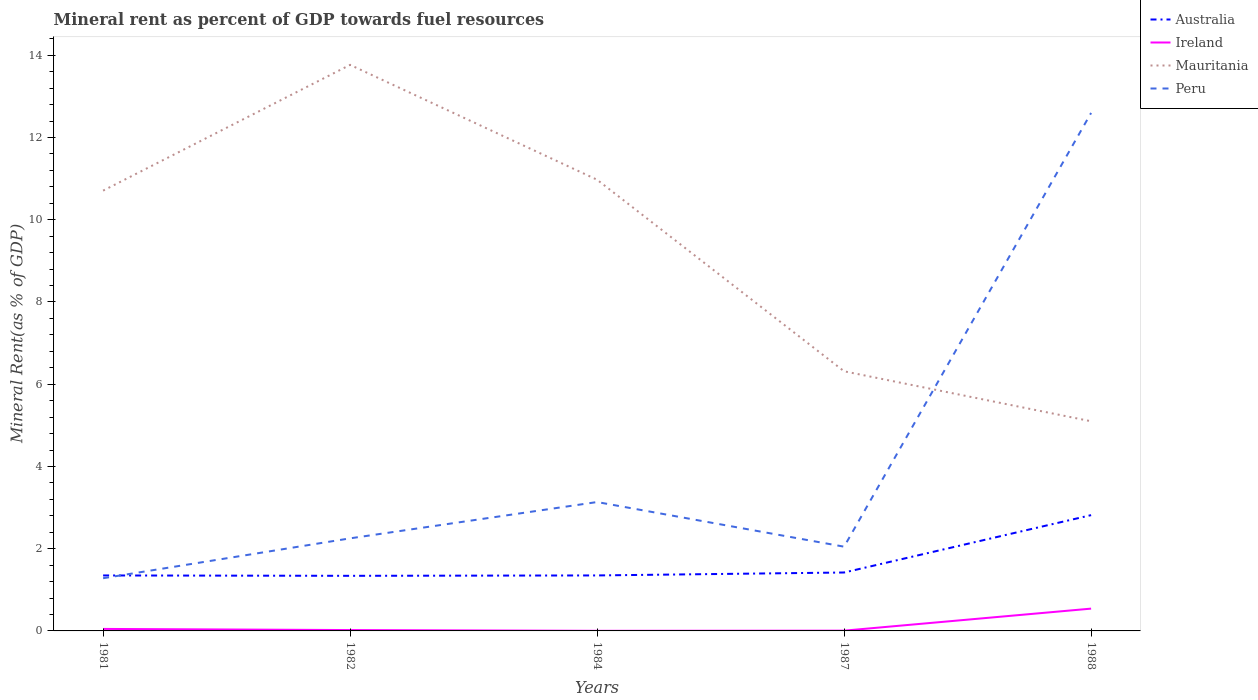Across all years, what is the maximum mineral rent in Mauritania?
Your answer should be very brief. 5.1. In which year was the mineral rent in Australia maximum?
Provide a short and direct response. 1982. What is the total mineral rent in Australia in the graph?
Provide a short and direct response. -0.08. What is the difference between the highest and the second highest mineral rent in Mauritania?
Make the answer very short. 8.67. How many lines are there?
Offer a very short reply. 4. How many years are there in the graph?
Your response must be concise. 5. What is the difference between two consecutive major ticks on the Y-axis?
Keep it short and to the point. 2. How many legend labels are there?
Give a very brief answer. 4. What is the title of the graph?
Offer a very short reply. Mineral rent as percent of GDP towards fuel resources. Does "Syrian Arab Republic" appear as one of the legend labels in the graph?
Ensure brevity in your answer.  No. What is the label or title of the Y-axis?
Provide a short and direct response. Mineral Rent(as % of GDP). What is the Mineral Rent(as % of GDP) in Australia in 1981?
Offer a very short reply. 1.35. What is the Mineral Rent(as % of GDP) in Ireland in 1981?
Provide a succinct answer. 0.05. What is the Mineral Rent(as % of GDP) of Mauritania in 1981?
Your answer should be very brief. 10.71. What is the Mineral Rent(as % of GDP) of Peru in 1981?
Offer a very short reply. 1.28. What is the Mineral Rent(as % of GDP) of Australia in 1982?
Make the answer very short. 1.34. What is the Mineral Rent(as % of GDP) of Ireland in 1982?
Offer a terse response. 0.02. What is the Mineral Rent(as % of GDP) in Mauritania in 1982?
Make the answer very short. 13.77. What is the Mineral Rent(as % of GDP) in Peru in 1982?
Provide a short and direct response. 2.25. What is the Mineral Rent(as % of GDP) of Australia in 1984?
Your response must be concise. 1.35. What is the Mineral Rent(as % of GDP) in Ireland in 1984?
Make the answer very short. 0. What is the Mineral Rent(as % of GDP) in Mauritania in 1984?
Your response must be concise. 10.97. What is the Mineral Rent(as % of GDP) in Peru in 1984?
Give a very brief answer. 3.13. What is the Mineral Rent(as % of GDP) in Australia in 1987?
Ensure brevity in your answer.  1.42. What is the Mineral Rent(as % of GDP) of Ireland in 1987?
Provide a succinct answer. 0.01. What is the Mineral Rent(as % of GDP) in Mauritania in 1987?
Give a very brief answer. 6.31. What is the Mineral Rent(as % of GDP) of Peru in 1987?
Make the answer very short. 2.05. What is the Mineral Rent(as % of GDP) of Australia in 1988?
Offer a very short reply. 2.82. What is the Mineral Rent(as % of GDP) of Ireland in 1988?
Your response must be concise. 0.54. What is the Mineral Rent(as % of GDP) in Mauritania in 1988?
Provide a short and direct response. 5.1. What is the Mineral Rent(as % of GDP) of Peru in 1988?
Ensure brevity in your answer.  12.6. Across all years, what is the maximum Mineral Rent(as % of GDP) of Australia?
Ensure brevity in your answer.  2.82. Across all years, what is the maximum Mineral Rent(as % of GDP) of Ireland?
Your response must be concise. 0.54. Across all years, what is the maximum Mineral Rent(as % of GDP) of Mauritania?
Keep it short and to the point. 13.77. Across all years, what is the maximum Mineral Rent(as % of GDP) in Peru?
Keep it short and to the point. 12.6. Across all years, what is the minimum Mineral Rent(as % of GDP) of Australia?
Your answer should be very brief. 1.34. Across all years, what is the minimum Mineral Rent(as % of GDP) in Ireland?
Keep it short and to the point. 0. Across all years, what is the minimum Mineral Rent(as % of GDP) of Mauritania?
Keep it short and to the point. 5.1. Across all years, what is the minimum Mineral Rent(as % of GDP) of Peru?
Provide a succinct answer. 1.28. What is the total Mineral Rent(as % of GDP) in Australia in the graph?
Give a very brief answer. 8.28. What is the total Mineral Rent(as % of GDP) in Ireland in the graph?
Offer a very short reply. 0.62. What is the total Mineral Rent(as % of GDP) in Mauritania in the graph?
Your answer should be compact. 46.86. What is the total Mineral Rent(as % of GDP) in Peru in the graph?
Offer a very short reply. 21.31. What is the difference between the Mineral Rent(as % of GDP) in Australia in 1981 and that in 1982?
Your response must be concise. 0.01. What is the difference between the Mineral Rent(as % of GDP) of Ireland in 1981 and that in 1982?
Offer a very short reply. 0.03. What is the difference between the Mineral Rent(as % of GDP) of Mauritania in 1981 and that in 1982?
Offer a very short reply. -3.06. What is the difference between the Mineral Rent(as % of GDP) in Peru in 1981 and that in 1982?
Provide a short and direct response. -0.97. What is the difference between the Mineral Rent(as % of GDP) of Australia in 1981 and that in 1984?
Your response must be concise. -0. What is the difference between the Mineral Rent(as % of GDP) of Ireland in 1981 and that in 1984?
Give a very brief answer. 0.05. What is the difference between the Mineral Rent(as % of GDP) of Mauritania in 1981 and that in 1984?
Make the answer very short. -0.27. What is the difference between the Mineral Rent(as % of GDP) of Peru in 1981 and that in 1984?
Provide a succinct answer. -1.85. What is the difference between the Mineral Rent(as % of GDP) of Australia in 1981 and that in 1987?
Provide a succinct answer. -0.07. What is the difference between the Mineral Rent(as % of GDP) in Ireland in 1981 and that in 1987?
Give a very brief answer. 0.04. What is the difference between the Mineral Rent(as % of GDP) in Mauritania in 1981 and that in 1987?
Your answer should be compact. 4.39. What is the difference between the Mineral Rent(as % of GDP) of Peru in 1981 and that in 1987?
Offer a terse response. -0.77. What is the difference between the Mineral Rent(as % of GDP) in Australia in 1981 and that in 1988?
Offer a terse response. -1.47. What is the difference between the Mineral Rent(as % of GDP) of Ireland in 1981 and that in 1988?
Your response must be concise. -0.49. What is the difference between the Mineral Rent(as % of GDP) in Mauritania in 1981 and that in 1988?
Offer a terse response. 5.61. What is the difference between the Mineral Rent(as % of GDP) in Peru in 1981 and that in 1988?
Offer a terse response. -11.32. What is the difference between the Mineral Rent(as % of GDP) in Australia in 1982 and that in 1984?
Keep it short and to the point. -0.01. What is the difference between the Mineral Rent(as % of GDP) of Ireland in 1982 and that in 1984?
Give a very brief answer. 0.02. What is the difference between the Mineral Rent(as % of GDP) of Mauritania in 1982 and that in 1984?
Provide a succinct answer. 2.79. What is the difference between the Mineral Rent(as % of GDP) of Peru in 1982 and that in 1984?
Your answer should be very brief. -0.88. What is the difference between the Mineral Rent(as % of GDP) in Australia in 1982 and that in 1987?
Your answer should be very brief. -0.08. What is the difference between the Mineral Rent(as % of GDP) in Ireland in 1982 and that in 1987?
Give a very brief answer. 0.01. What is the difference between the Mineral Rent(as % of GDP) in Mauritania in 1982 and that in 1987?
Your answer should be compact. 7.45. What is the difference between the Mineral Rent(as % of GDP) of Peru in 1982 and that in 1987?
Your answer should be compact. 0.2. What is the difference between the Mineral Rent(as % of GDP) of Australia in 1982 and that in 1988?
Give a very brief answer. -1.48. What is the difference between the Mineral Rent(as % of GDP) in Ireland in 1982 and that in 1988?
Your answer should be very brief. -0.52. What is the difference between the Mineral Rent(as % of GDP) in Mauritania in 1982 and that in 1988?
Your answer should be compact. 8.67. What is the difference between the Mineral Rent(as % of GDP) of Peru in 1982 and that in 1988?
Your answer should be very brief. -10.35. What is the difference between the Mineral Rent(as % of GDP) of Australia in 1984 and that in 1987?
Your answer should be compact. -0.07. What is the difference between the Mineral Rent(as % of GDP) in Ireland in 1984 and that in 1987?
Offer a terse response. -0. What is the difference between the Mineral Rent(as % of GDP) in Mauritania in 1984 and that in 1987?
Make the answer very short. 4.66. What is the difference between the Mineral Rent(as % of GDP) in Peru in 1984 and that in 1987?
Give a very brief answer. 1.09. What is the difference between the Mineral Rent(as % of GDP) in Australia in 1984 and that in 1988?
Keep it short and to the point. -1.47. What is the difference between the Mineral Rent(as % of GDP) in Ireland in 1984 and that in 1988?
Your answer should be very brief. -0.54. What is the difference between the Mineral Rent(as % of GDP) of Mauritania in 1984 and that in 1988?
Provide a short and direct response. 5.87. What is the difference between the Mineral Rent(as % of GDP) of Peru in 1984 and that in 1988?
Your answer should be compact. -9.46. What is the difference between the Mineral Rent(as % of GDP) in Australia in 1987 and that in 1988?
Your response must be concise. -1.4. What is the difference between the Mineral Rent(as % of GDP) in Ireland in 1987 and that in 1988?
Keep it short and to the point. -0.54. What is the difference between the Mineral Rent(as % of GDP) of Mauritania in 1987 and that in 1988?
Keep it short and to the point. 1.22. What is the difference between the Mineral Rent(as % of GDP) of Peru in 1987 and that in 1988?
Your answer should be very brief. -10.55. What is the difference between the Mineral Rent(as % of GDP) in Australia in 1981 and the Mineral Rent(as % of GDP) in Ireland in 1982?
Make the answer very short. 1.33. What is the difference between the Mineral Rent(as % of GDP) of Australia in 1981 and the Mineral Rent(as % of GDP) of Mauritania in 1982?
Provide a succinct answer. -12.42. What is the difference between the Mineral Rent(as % of GDP) in Australia in 1981 and the Mineral Rent(as % of GDP) in Peru in 1982?
Provide a short and direct response. -0.9. What is the difference between the Mineral Rent(as % of GDP) of Ireland in 1981 and the Mineral Rent(as % of GDP) of Mauritania in 1982?
Provide a succinct answer. -13.72. What is the difference between the Mineral Rent(as % of GDP) of Ireland in 1981 and the Mineral Rent(as % of GDP) of Peru in 1982?
Keep it short and to the point. -2.2. What is the difference between the Mineral Rent(as % of GDP) of Mauritania in 1981 and the Mineral Rent(as % of GDP) of Peru in 1982?
Provide a succinct answer. 8.46. What is the difference between the Mineral Rent(as % of GDP) of Australia in 1981 and the Mineral Rent(as % of GDP) of Ireland in 1984?
Your answer should be compact. 1.35. What is the difference between the Mineral Rent(as % of GDP) in Australia in 1981 and the Mineral Rent(as % of GDP) in Mauritania in 1984?
Your answer should be very brief. -9.62. What is the difference between the Mineral Rent(as % of GDP) in Australia in 1981 and the Mineral Rent(as % of GDP) in Peru in 1984?
Provide a short and direct response. -1.79. What is the difference between the Mineral Rent(as % of GDP) of Ireland in 1981 and the Mineral Rent(as % of GDP) of Mauritania in 1984?
Your response must be concise. -10.92. What is the difference between the Mineral Rent(as % of GDP) of Ireland in 1981 and the Mineral Rent(as % of GDP) of Peru in 1984?
Give a very brief answer. -3.09. What is the difference between the Mineral Rent(as % of GDP) of Mauritania in 1981 and the Mineral Rent(as % of GDP) of Peru in 1984?
Offer a terse response. 7.57. What is the difference between the Mineral Rent(as % of GDP) of Australia in 1981 and the Mineral Rent(as % of GDP) of Ireland in 1987?
Make the answer very short. 1.34. What is the difference between the Mineral Rent(as % of GDP) of Australia in 1981 and the Mineral Rent(as % of GDP) of Mauritania in 1987?
Keep it short and to the point. -4.97. What is the difference between the Mineral Rent(as % of GDP) in Australia in 1981 and the Mineral Rent(as % of GDP) in Peru in 1987?
Keep it short and to the point. -0.7. What is the difference between the Mineral Rent(as % of GDP) of Ireland in 1981 and the Mineral Rent(as % of GDP) of Mauritania in 1987?
Give a very brief answer. -6.27. What is the difference between the Mineral Rent(as % of GDP) in Ireland in 1981 and the Mineral Rent(as % of GDP) in Peru in 1987?
Provide a short and direct response. -2. What is the difference between the Mineral Rent(as % of GDP) of Mauritania in 1981 and the Mineral Rent(as % of GDP) of Peru in 1987?
Offer a very short reply. 8.66. What is the difference between the Mineral Rent(as % of GDP) in Australia in 1981 and the Mineral Rent(as % of GDP) in Ireland in 1988?
Your response must be concise. 0.81. What is the difference between the Mineral Rent(as % of GDP) of Australia in 1981 and the Mineral Rent(as % of GDP) of Mauritania in 1988?
Provide a short and direct response. -3.75. What is the difference between the Mineral Rent(as % of GDP) in Australia in 1981 and the Mineral Rent(as % of GDP) in Peru in 1988?
Make the answer very short. -11.25. What is the difference between the Mineral Rent(as % of GDP) in Ireland in 1981 and the Mineral Rent(as % of GDP) in Mauritania in 1988?
Provide a succinct answer. -5.05. What is the difference between the Mineral Rent(as % of GDP) of Ireland in 1981 and the Mineral Rent(as % of GDP) of Peru in 1988?
Offer a very short reply. -12.55. What is the difference between the Mineral Rent(as % of GDP) of Mauritania in 1981 and the Mineral Rent(as % of GDP) of Peru in 1988?
Keep it short and to the point. -1.89. What is the difference between the Mineral Rent(as % of GDP) in Australia in 1982 and the Mineral Rent(as % of GDP) in Ireland in 1984?
Make the answer very short. 1.34. What is the difference between the Mineral Rent(as % of GDP) of Australia in 1982 and the Mineral Rent(as % of GDP) of Mauritania in 1984?
Your response must be concise. -9.63. What is the difference between the Mineral Rent(as % of GDP) in Australia in 1982 and the Mineral Rent(as % of GDP) in Peru in 1984?
Your answer should be very brief. -1.79. What is the difference between the Mineral Rent(as % of GDP) of Ireland in 1982 and the Mineral Rent(as % of GDP) of Mauritania in 1984?
Ensure brevity in your answer.  -10.95. What is the difference between the Mineral Rent(as % of GDP) in Ireland in 1982 and the Mineral Rent(as % of GDP) in Peru in 1984?
Make the answer very short. -3.11. What is the difference between the Mineral Rent(as % of GDP) in Mauritania in 1982 and the Mineral Rent(as % of GDP) in Peru in 1984?
Your answer should be compact. 10.63. What is the difference between the Mineral Rent(as % of GDP) in Australia in 1982 and the Mineral Rent(as % of GDP) in Ireland in 1987?
Offer a terse response. 1.33. What is the difference between the Mineral Rent(as % of GDP) of Australia in 1982 and the Mineral Rent(as % of GDP) of Mauritania in 1987?
Offer a very short reply. -4.97. What is the difference between the Mineral Rent(as % of GDP) of Australia in 1982 and the Mineral Rent(as % of GDP) of Peru in 1987?
Give a very brief answer. -0.71. What is the difference between the Mineral Rent(as % of GDP) in Ireland in 1982 and the Mineral Rent(as % of GDP) in Mauritania in 1987?
Offer a terse response. -6.29. What is the difference between the Mineral Rent(as % of GDP) in Ireland in 1982 and the Mineral Rent(as % of GDP) in Peru in 1987?
Offer a terse response. -2.03. What is the difference between the Mineral Rent(as % of GDP) of Mauritania in 1982 and the Mineral Rent(as % of GDP) of Peru in 1987?
Your response must be concise. 11.72. What is the difference between the Mineral Rent(as % of GDP) of Australia in 1982 and the Mineral Rent(as % of GDP) of Ireland in 1988?
Your answer should be very brief. 0.8. What is the difference between the Mineral Rent(as % of GDP) in Australia in 1982 and the Mineral Rent(as % of GDP) in Mauritania in 1988?
Provide a succinct answer. -3.76. What is the difference between the Mineral Rent(as % of GDP) of Australia in 1982 and the Mineral Rent(as % of GDP) of Peru in 1988?
Give a very brief answer. -11.26. What is the difference between the Mineral Rent(as % of GDP) in Ireland in 1982 and the Mineral Rent(as % of GDP) in Mauritania in 1988?
Ensure brevity in your answer.  -5.08. What is the difference between the Mineral Rent(as % of GDP) of Ireland in 1982 and the Mineral Rent(as % of GDP) of Peru in 1988?
Make the answer very short. -12.58. What is the difference between the Mineral Rent(as % of GDP) in Mauritania in 1982 and the Mineral Rent(as % of GDP) in Peru in 1988?
Offer a terse response. 1.17. What is the difference between the Mineral Rent(as % of GDP) in Australia in 1984 and the Mineral Rent(as % of GDP) in Ireland in 1987?
Your answer should be very brief. 1.34. What is the difference between the Mineral Rent(as % of GDP) of Australia in 1984 and the Mineral Rent(as % of GDP) of Mauritania in 1987?
Provide a succinct answer. -4.96. What is the difference between the Mineral Rent(as % of GDP) in Australia in 1984 and the Mineral Rent(as % of GDP) in Peru in 1987?
Provide a short and direct response. -0.7. What is the difference between the Mineral Rent(as % of GDP) in Ireland in 1984 and the Mineral Rent(as % of GDP) in Mauritania in 1987?
Give a very brief answer. -6.31. What is the difference between the Mineral Rent(as % of GDP) of Ireland in 1984 and the Mineral Rent(as % of GDP) of Peru in 1987?
Your response must be concise. -2.05. What is the difference between the Mineral Rent(as % of GDP) of Mauritania in 1984 and the Mineral Rent(as % of GDP) of Peru in 1987?
Make the answer very short. 8.92. What is the difference between the Mineral Rent(as % of GDP) of Australia in 1984 and the Mineral Rent(as % of GDP) of Ireland in 1988?
Your answer should be compact. 0.81. What is the difference between the Mineral Rent(as % of GDP) of Australia in 1984 and the Mineral Rent(as % of GDP) of Mauritania in 1988?
Your response must be concise. -3.75. What is the difference between the Mineral Rent(as % of GDP) in Australia in 1984 and the Mineral Rent(as % of GDP) in Peru in 1988?
Your response must be concise. -11.25. What is the difference between the Mineral Rent(as % of GDP) of Ireland in 1984 and the Mineral Rent(as % of GDP) of Mauritania in 1988?
Provide a succinct answer. -5.1. What is the difference between the Mineral Rent(as % of GDP) in Ireland in 1984 and the Mineral Rent(as % of GDP) in Peru in 1988?
Your response must be concise. -12.6. What is the difference between the Mineral Rent(as % of GDP) of Mauritania in 1984 and the Mineral Rent(as % of GDP) of Peru in 1988?
Provide a short and direct response. -1.62. What is the difference between the Mineral Rent(as % of GDP) in Australia in 1987 and the Mineral Rent(as % of GDP) in Ireland in 1988?
Your answer should be compact. 0.88. What is the difference between the Mineral Rent(as % of GDP) in Australia in 1987 and the Mineral Rent(as % of GDP) in Mauritania in 1988?
Your answer should be very brief. -3.68. What is the difference between the Mineral Rent(as % of GDP) in Australia in 1987 and the Mineral Rent(as % of GDP) in Peru in 1988?
Offer a terse response. -11.18. What is the difference between the Mineral Rent(as % of GDP) in Ireland in 1987 and the Mineral Rent(as % of GDP) in Mauritania in 1988?
Offer a very short reply. -5.09. What is the difference between the Mineral Rent(as % of GDP) of Ireland in 1987 and the Mineral Rent(as % of GDP) of Peru in 1988?
Ensure brevity in your answer.  -12.59. What is the difference between the Mineral Rent(as % of GDP) of Mauritania in 1987 and the Mineral Rent(as % of GDP) of Peru in 1988?
Your answer should be very brief. -6.28. What is the average Mineral Rent(as % of GDP) of Australia per year?
Offer a very short reply. 1.66. What is the average Mineral Rent(as % of GDP) of Ireland per year?
Offer a very short reply. 0.12. What is the average Mineral Rent(as % of GDP) in Mauritania per year?
Offer a very short reply. 9.37. What is the average Mineral Rent(as % of GDP) of Peru per year?
Your answer should be compact. 4.26. In the year 1981, what is the difference between the Mineral Rent(as % of GDP) of Australia and Mineral Rent(as % of GDP) of Ireland?
Your response must be concise. 1.3. In the year 1981, what is the difference between the Mineral Rent(as % of GDP) in Australia and Mineral Rent(as % of GDP) in Mauritania?
Offer a very short reply. -9.36. In the year 1981, what is the difference between the Mineral Rent(as % of GDP) in Australia and Mineral Rent(as % of GDP) in Peru?
Provide a succinct answer. 0.07. In the year 1981, what is the difference between the Mineral Rent(as % of GDP) of Ireland and Mineral Rent(as % of GDP) of Mauritania?
Give a very brief answer. -10.66. In the year 1981, what is the difference between the Mineral Rent(as % of GDP) in Ireland and Mineral Rent(as % of GDP) in Peru?
Provide a succinct answer. -1.23. In the year 1981, what is the difference between the Mineral Rent(as % of GDP) of Mauritania and Mineral Rent(as % of GDP) of Peru?
Offer a terse response. 9.43. In the year 1982, what is the difference between the Mineral Rent(as % of GDP) of Australia and Mineral Rent(as % of GDP) of Ireland?
Your answer should be compact. 1.32. In the year 1982, what is the difference between the Mineral Rent(as % of GDP) in Australia and Mineral Rent(as % of GDP) in Mauritania?
Your response must be concise. -12.43. In the year 1982, what is the difference between the Mineral Rent(as % of GDP) of Australia and Mineral Rent(as % of GDP) of Peru?
Provide a short and direct response. -0.91. In the year 1982, what is the difference between the Mineral Rent(as % of GDP) in Ireland and Mineral Rent(as % of GDP) in Mauritania?
Give a very brief answer. -13.75. In the year 1982, what is the difference between the Mineral Rent(as % of GDP) of Ireland and Mineral Rent(as % of GDP) of Peru?
Ensure brevity in your answer.  -2.23. In the year 1982, what is the difference between the Mineral Rent(as % of GDP) in Mauritania and Mineral Rent(as % of GDP) in Peru?
Your answer should be compact. 11.52. In the year 1984, what is the difference between the Mineral Rent(as % of GDP) in Australia and Mineral Rent(as % of GDP) in Ireland?
Your response must be concise. 1.35. In the year 1984, what is the difference between the Mineral Rent(as % of GDP) in Australia and Mineral Rent(as % of GDP) in Mauritania?
Offer a very short reply. -9.62. In the year 1984, what is the difference between the Mineral Rent(as % of GDP) of Australia and Mineral Rent(as % of GDP) of Peru?
Ensure brevity in your answer.  -1.78. In the year 1984, what is the difference between the Mineral Rent(as % of GDP) of Ireland and Mineral Rent(as % of GDP) of Mauritania?
Provide a short and direct response. -10.97. In the year 1984, what is the difference between the Mineral Rent(as % of GDP) of Ireland and Mineral Rent(as % of GDP) of Peru?
Your answer should be very brief. -3.13. In the year 1984, what is the difference between the Mineral Rent(as % of GDP) in Mauritania and Mineral Rent(as % of GDP) in Peru?
Give a very brief answer. 7.84. In the year 1987, what is the difference between the Mineral Rent(as % of GDP) of Australia and Mineral Rent(as % of GDP) of Ireland?
Your response must be concise. 1.41. In the year 1987, what is the difference between the Mineral Rent(as % of GDP) in Australia and Mineral Rent(as % of GDP) in Mauritania?
Offer a terse response. -4.89. In the year 1987, what is the difference between the Mineral Rent(as % of GDP) of Australia and Mineral Rent(as % of GDP) of Peru?
Make the answer very short. -0.63. In the year 1987, what is the difference between the Mineral Rent(as % of GDP) of Ireland and Mineral Rent(as % of GDP) of Mauritania?
Offer a very short reply. -6.31. In the year 1987, what is the difference between the Mineral Rent(as % of GDP) in Ireland and Mineral Rent(as % of GDP) in Peru?
Provide a succinct answer. -2.04. In the year 1987, what is the difference between the Mineral Rent(as % of GDP) in Mauritania and Mineral Rent(as % of GDP) in Peru?
Provide a short and direct response. 4.27. In the year 1988, what is the difference between the Mineral Rent(as % of GDP) of Australia and Mineral Rent(as % of GDP) of Ireland?
Ensure brevity in your answer.  2.27. In the year 1988, what is the difference between the Mineral Rent(as % of GDP) of Australia and Mineral Rent(as % of GDP) of Mauritania?
Provide a succinct answer. -2.28. In the year 1988, what is the difference between the Mineral Rent(as % of GDP) in Australia and Mineral Rent(as % of GDP) in Peru?
Your answer should be very brief. -9.78. In the year 1988, what is the difference between the Mineral Rent(as % of GDP) of Ireland and Mineral Rent(as % of GDP) of Mauritania?
Provide a short and direct response. -4.56. In the year 1988, what is the difference between the Mineral Rent(as % of GDP) in Ireland and Mineral Rent(as % of GDP) in Peru?
Provide a short and direct response. -12.06. In the year 1988, what is the difference between the Mineral Rent(as % of GDP) in Mauritania and Mineral Rent(as % of GDP) in Peru?
Make the answer very short. -7.5. What is the ratio of the Mineral Rent(as % of GDP) in Australia in 1981 to that in 1982?
Give a very brief answer. 1.01. What is the ratio of the Mineral Rent(as % of GDP) of Ireland in 1981 to that in 1982?
Your answer should be compact. 2.33. What is the ratio of the Mineral Rent(as % of GDP) in Peru in 1981 to that in 1982?
Offer a terse response. 0.57. What is the ratio of the Mineral Rent(as % of GDP) in Ireland in 1981 to that in 1984?
Your response must be concise. 17.88. What is the ratio of the Mineral Rent(as % of GDP) of Mauritania in 1981 to that in 1984?
Your answer should be very brief. 0.98. What is the ratio of the Mineral Rent(as % of GDP) of Peru in 1981 to that in 1984?
Provide a short and direct response. 0.41. What is the ratio of the Mineral Rent(as % of GDP) of Australia in 1981 to that in 1987?
Offer a terse response. 0.95. What is the ratio of the Mineral Rent(as % of GDP) of Ireland in 1981 to that in 1987?
Offer a terse response. 7.66. What is the ratio of the Mineral Rent(as % of GDP) of Mauritania in 1981 to that in 1987?
Make the answer very short. 1.7. What is the ratio of the Mineral Rent(as % of GDP) in Peru in 1981 to that in 1987?
Provide a short and direct response. 0.63. What is the ratio of the Mineral Rent(as % of GDP) in Australia in 1981 to that in 1988?
Provide a succinct answer. 0.48. What is the ratio of the Mineral Rent(as % of GDP) in Ireland in 1981 to that in 1988?
Offer a very short reply. 0.09. What is the ratio of the Mineral Rent(as % of GDP) in Mauritania in 1981 to that in 1988?
Offer a terse response. 2.1. What is the ratio of the Mineral Rent(as % of GDP) in Peru in 1981 to that in 1988?
Your answer should be compact. 0.1. What is the ratio of the Mineral Rent(as % of GDP) in Ireland in 1982 to that in 1984?
Your answer should be very brief. 7.68. What is the ratio of the Mineral Rent(as % of GDP) of Mauritania in 1982 to that in 1984?
Your answer should be very brief. 1.25. What is the ratio of the Mineral Rent(as % of GDP) in Peru in 1982 to that in 1984?
Your answer should be compact. 0.72. What is the ratio of the Mineral Rent(as % of GDP) in Australia in 1982 to that in 1987?
Provide a short and direct response. 0.94. What is the ratio of the Mineral Rent(as % of GDP) of Ireland in 1982 to that in 1987?
Provide a short and direct response. 3.29. What is the ratio of the Mineral Rent(as % of GDP) in Mauritania in 1982 to that in 1987?
Your response must be concise. 2.18. What is the ratio of the Mineral Rent(as % of GDP) of Peru in 1982 to that in 1987?
Your answer should be compact. 1.1. What is the ratio of the Mineral Rent(as % of GDP) of Australia in 1982 to that in 1988?
Provide a succinct answer. 0.48. What is the ratio of the Mineral Rent(as % of GDP) in Ireland in 1982 to that in 1988?
Make the answer very short. 0.04. What is the ratio of the Mineral Rent(as % of GDP) in Mauritania in 1982 to that in 1988?
Your answer should be very brief. 2.7. What is the ratio of the Mineral Rent(as % of GDP) of Peru in 1982 to that in 1988?
Give a very brief answer. 0.18. What is the ratio of the Mineral Rent(as % of GDP) in Australia in 1984 to that in 1987?
Offer a very short reply. 0.95. What is the ratio of the Mineral Rent(as % of GDP) in Ireland in 1984 to that in 1987?
Your answer should be compact. 0.43. What is the ratio of the Mineral Rent(as % of GDP) in Mauritania in 1984 to that in 1987?
Offer a terse response. 1.74. What is the ratio of the Mineral Rent(as % of GDP) of Peru in 1984 to that in 1987?
Your response must be concise. 1.53. What is the ratio of the Mineral Rent(as % of GDP) in Australia in 1984 to that in 1988?
Your response must be concise. 0.48. What is the ratio of the Mineral Rent(as % of GDP) in Ireland in 1984 to that in 1988?
Make the answer very short. 0.01. What is the ratio of the Mineral Rent(as % of GDP) of Mauritania in 1984 to that in 1988?
Offer a very short reply. 2.15. What is the ratio of the Mineral Rent(as % of GDP) in Peru in 1984 to that in 1988?
Ensure brevity in your answer.  0.25. What is the ratio of the Mineral Rent(as % of GDP) of Australia in 1987 to that in 1988?
Offer a very short reply. 0.5. What is the ratio of the Mineral Rent(as % of GDP) of Ireland in 1987 to that in 1988?
Your answer should be very brief. 0.01. What is the ratio of the Mineral Rent(as % of GDP) in Mauritania in 1987 to that in 1988?
Offer a very short reply. 1.24. What is the ratio of the Mineral Rent(as % of GDP) of Peru in 1987 to that in 1988?
Give a very brief answer. 0.16. What is the difference between the highest and the second highest Mineral Rent(as % of GDP) of Australia?
Offer a very short reply. 1.4. What is the difference between the highest and the second highest Mineral Rent(as % of GDP) of Ireland?
Make the answer very short. 0.49. What is the difference between the highest and the second highest Mineral Rent(as % of GDP) in Mauritania?
Offer a very short reply. 2.79. What is the difference between the highest and the second highest Mineral Rent(as % of GDP) of Peru?
Your response must be concise. 9.46. What is the difference between the highest and the lowest Mineral Rent(as % of GDP) of Australia?
Your response must be concise. 1.48. What is the difference between the highest and the lowest Mineral Rent(as % of GDP) in Ireland?
Offer a very short reply. 0.54. What is the difference between the highest and the lowest Mineral Rent(as % of GDP) of Mauritania?
Your response must be concise. 8.67. What is the difference between the highest and the lowest Mineral Rent(as % of GDP) of Peru?
Your answer should be compact. 11.32. 